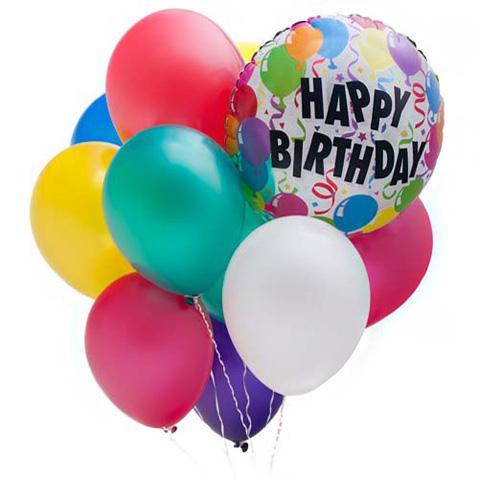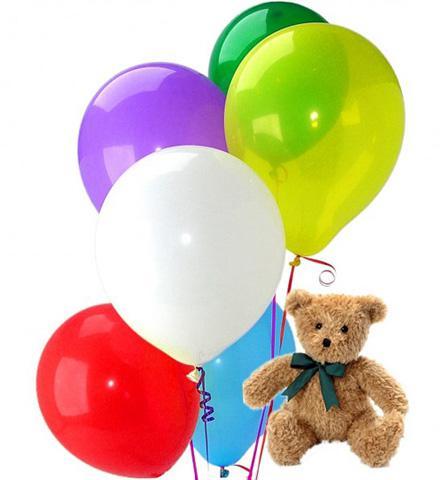The first image is the image on the left, the second image is the image on the right. Examine the images to the left and right. Is the description "In one of the images there is a stuffed bear next to multiple solid colored balloons." accurate? Answer yes or no. Yes. 